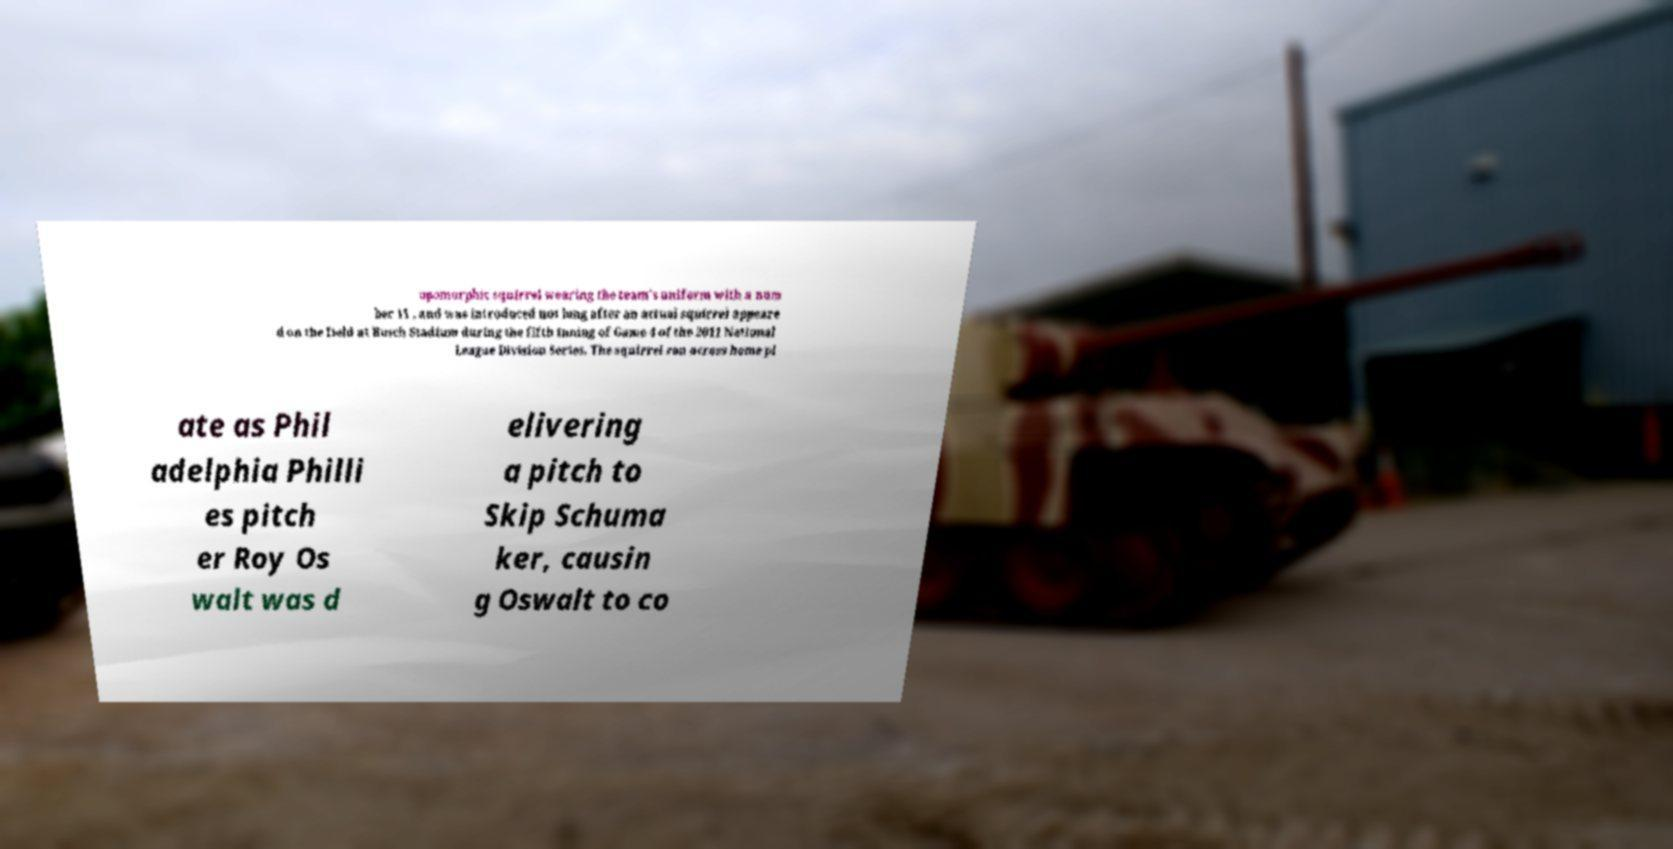I need the written content from this picture converted into text. Can you do that? opomorphic squirrel wearing the team's uniform with a num ber 11 , and was introduced not long after an actual squirrel appeare d on the field at Busch Stadium during the fifth inning of Game 4 of the 2011 National League Division Series. The squirrel ran across home pl ate as Phil adelphia Philli es pitch er Roy Os walt was d elivering a pitch to Skip Schuma ker, causin g Oswalt to co 